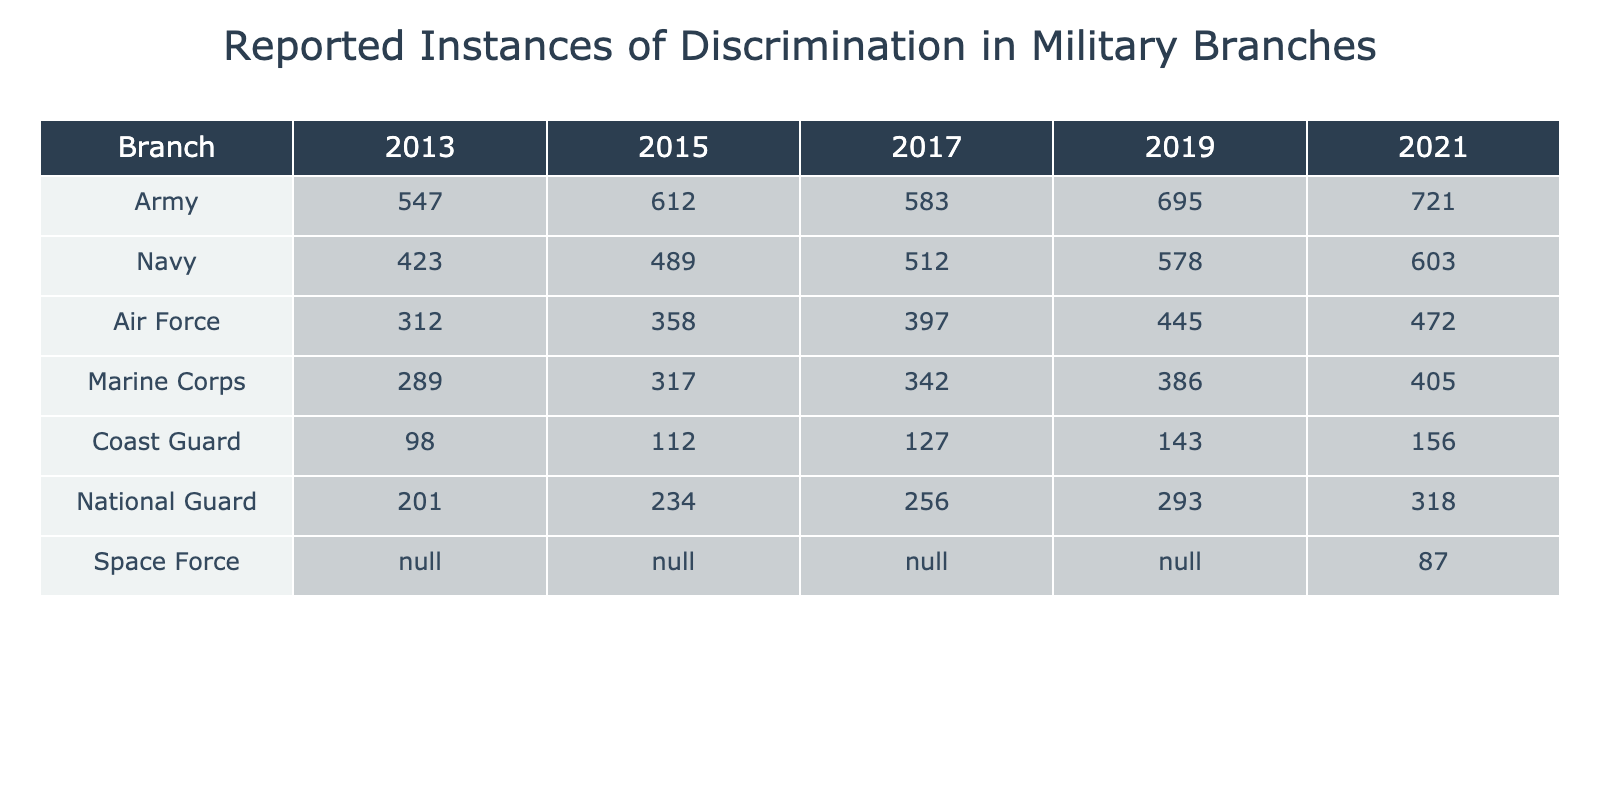What was the reported instance of discrimination in the Army in 2021? The table shows that in 2021, the reported instance of discrimination in the Army was 721.
Answer: 721 Which military branch had the lowest reported instances of discrimination in 2015? According to the table, the Coast Guard had the lowest reported instances of discrimination in 2015 with a total of 112 cases.
Answer: 112 What is the difference in reported instances of discrimination between the Navy in 2019 and the Air Force in 2019? The Navy reported 578 instances in 2019, while the Air Force reported 445 cases. The difference is 578 - 445 = 133.
Answer: 133 What is the average number of reported instances of discrimination for the Marine Corps over the years reported? The Marine Corps had reported instances of 289, 317, 342, 386, and 405. The average is calculated as (289 + 317 + 342 + 386 + 405) / 5 = 339.8, rounding it gives an average of 340.
Answer: 340 Does the Space Force have any reported instances of discrimination in the years prior to 2021? The table indicates that the Space Force does not have reported instances for the years prior to 2021, which confirms as the entries state 'N/A'.
Answer: No Which branch saw the highest increase in reported discrimination instances from 2013 to 2021? Calculating the differences: Army increased from 547 to 721 (174), Navy from 423 to 603 (180), Air Force from 312 to 472 (160), Marine Corps from 289 to 405 (116), Coast Guard from 98 to 156 (58), and National Guard from 201 to 318 (117). Thus, the Navy saw the highest increase with 180 cases.
Answer: Navy What was the reported instances of discrimination in the National Guard in 2019? According to the table, the National Guard had 293 reported instances of discrimination in 2019.
Answer: 293 If we combine the reported instances from the Coast Guard and the Marine Corps for 2021, what would be the total? The Coast Guard reported 156 instances and the Marine Corps reported 405 in 2021. Adding these together gives 156 + 405 = 561.
Answer: 561 In which year did the Air Force see its highest reported discrimination instances? The table indicates the Air Force had its highest reported instances in 2021 with a total of 472.
Answer: 2021 Is it true that the Army reported more instances of discrimination than the Coast Guard in 2019? Yes, in 2019, the Army reported 695 instances while the Coast Guard had 143, which confirms the statement is true.
Answer: Yes What percentage increase in reported discrimination instances did the Army experience from 2013 to 2021? The Army's instances increased from 547 to 721, which is a change of 721 - 547 = 174. The percentage increase is (174 / 547) * 100 ≈ 31.8%.
Answer: 31.8% 